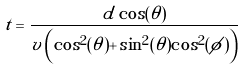Convert formula to latex. <formula><loc_0><loc_0><loc_500><loc_500>t = \frac { d \cos ( \theta ) } { v \left ( \cos ^ { 2 } ( \theta ) + \sin ^ { 2 } ( \theta ) \cos ^ { 2 } ( \phi ) \right ) } \\</formula> 